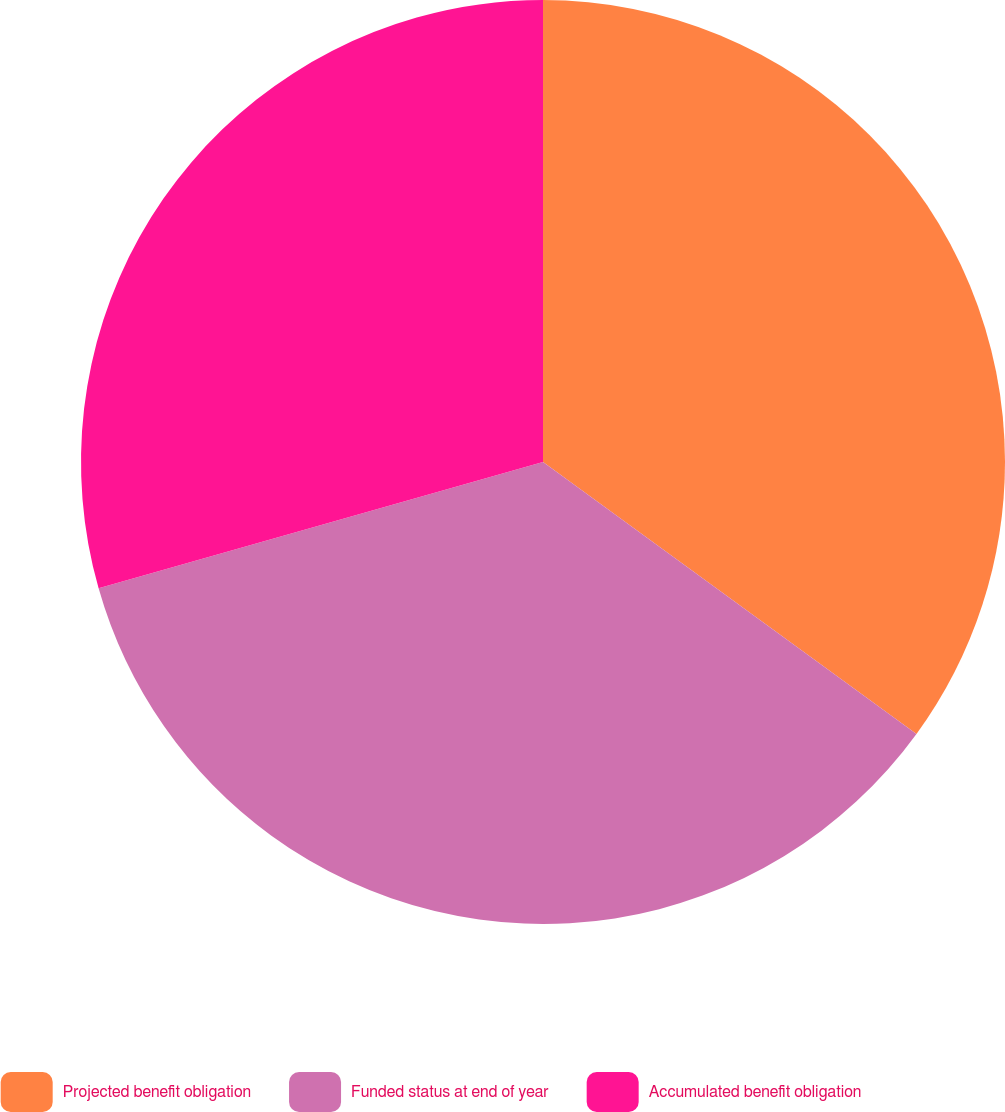Convert chart. <chart><loc_0><loc_0><loc_500><loc_500><pie_chart><fcel>Projected benefit obligation<fcel>Funded status at end of year<fcel>Accumulated benefit obligation<nl><fcel>35.02%<fcel>35.58%<fcel>29.41%<nl></chart> 